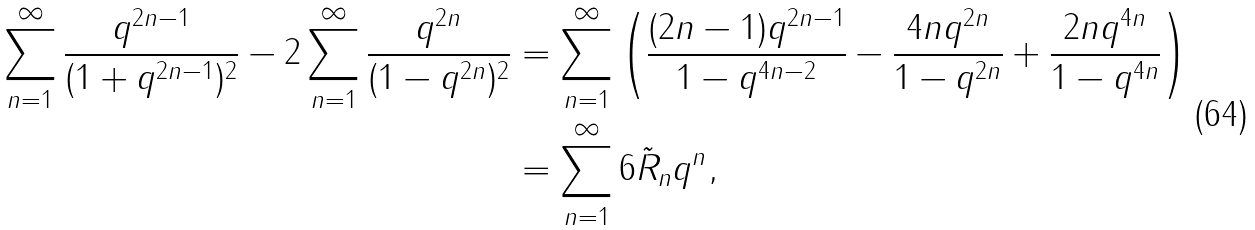Convert formula to latex. <formula><loc_0><loc_0><loc_500><loc_500>\sum _ { n = 1 } ^ { \infty } \frac { q ^ { 2 n - 1 } } { ( 1 + q ^ { 2 n - 1 } ) ^ { 2 } } - 2 \sum _ { n = 1 } ^ { \infty } \frac { q ^ { 2 n } } { ( 1 - q ^ { 2 n } ) ^ { 2 } } & = \sum _ { n = 1 } ^ { \infty } \left ( \frac { ( 2 n - 1 ) q ^ { 2 n - 1 } } { 1 - q ^ { 4 n - 2 } } - \frac { 4 n q ^ { 2 n } } { 1 - q ^ { 2 n } } + \frac { 2 n q ^ { 4 n } } { 1 - q ^ { 4 n } } \right ) \\ & = \sum _ { n = 1 } ^ { \infty } 6 \tilde { R } _ { n } q ^ { n } ,</formula> 